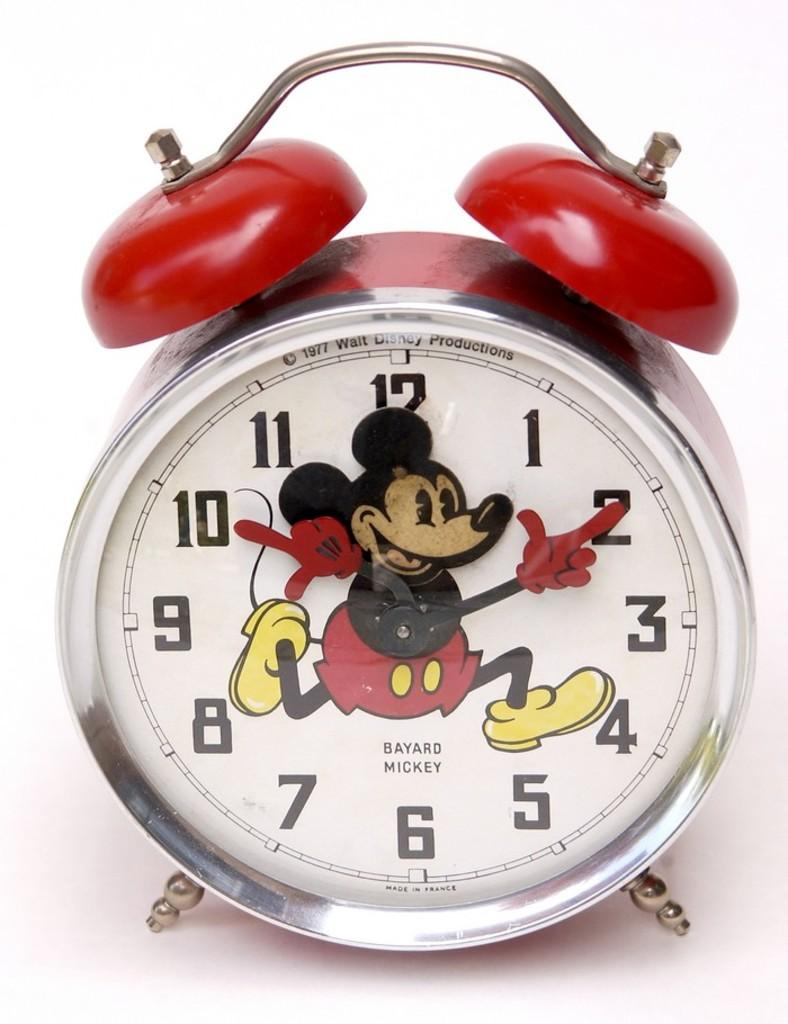<image>
Offer a succinct explanation of the picture presented. A 1977 Mickey Mouse clock was made in France. 